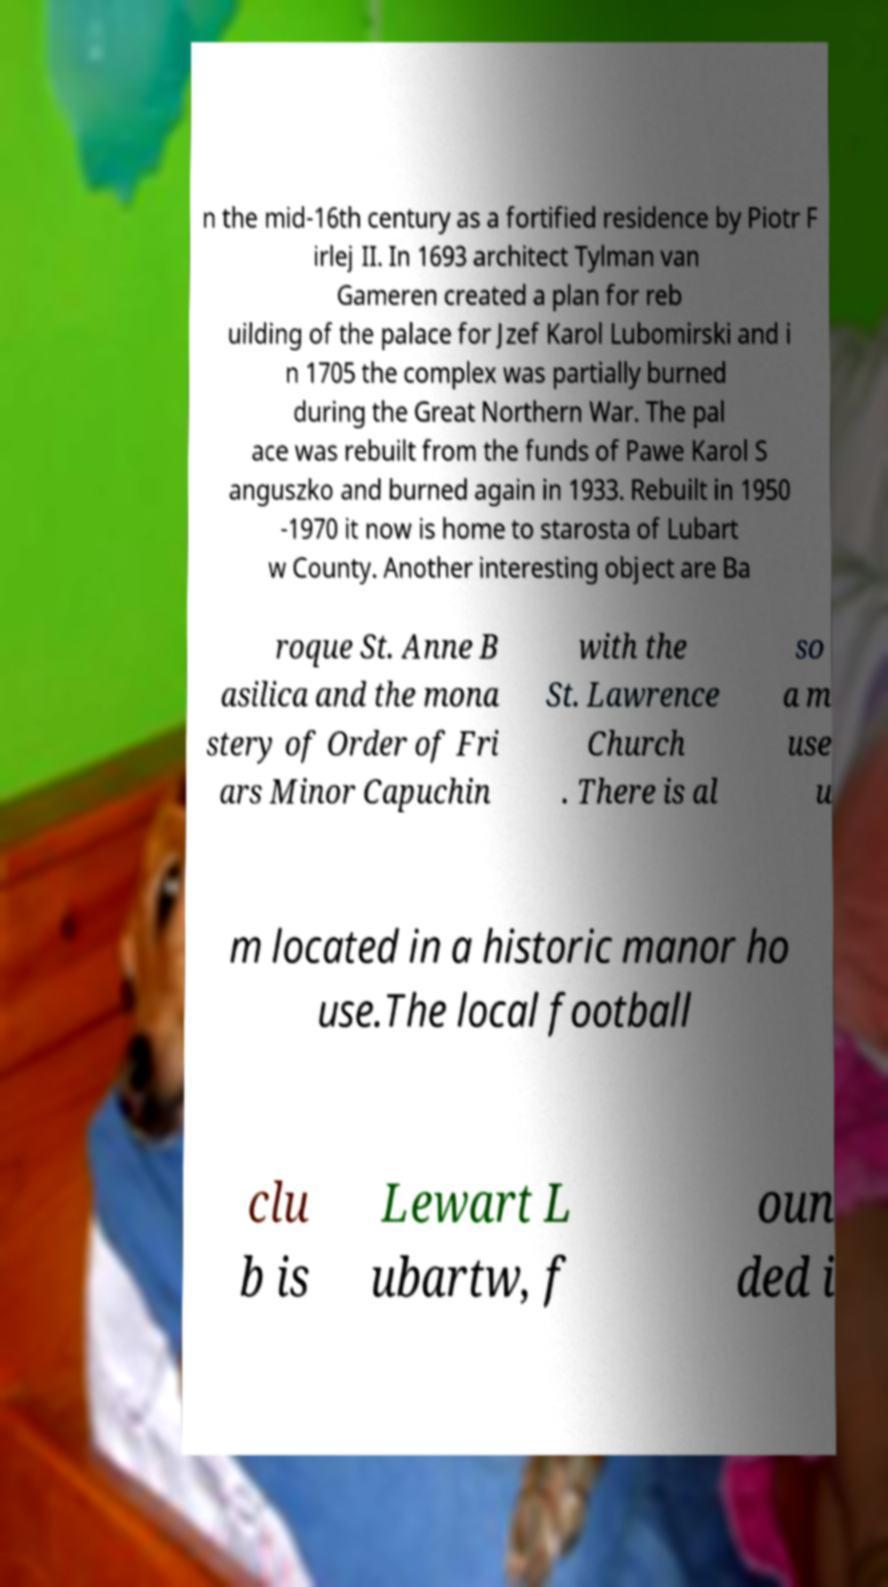Could you assist in decoding the text presented in this image and type it out clearly? n the mid-16th century as a fortified residence by Piotr F irlej II. In 1693 architect Tylman van Gameren created a plan for reb uilding of the palace for Jzef Karol Lubomirski and i n 1705 the complex was partially burned during the Great Northern War. The pal ace was rebuilt from the funds of Pawe Karol S anguszko and burned again in 1933. Rebuilt in 1950 -1970 it now is home to starosta of Lubart w County. Another interesting object are Ba roque St. Anne B asilica and the mona stery of Order of Fri ars Minor Capuchin with the St. Lawrence Church . There is al so a m use u m located in a historic manor ho use.The local football clu b is Lewart L ubartw, f oun ded i 